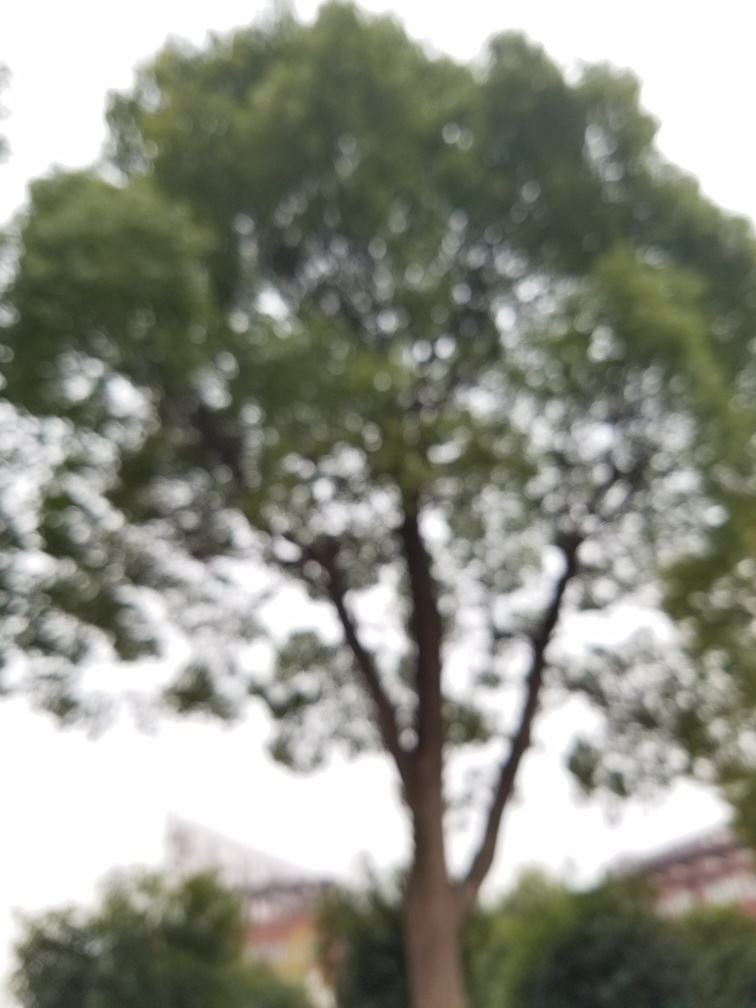What time of day does this photo seem to have been taken? The lighting in the photo suggests overcast conditions or possibly the light of early morning or late afternoon. However, the lack of shadows and direct light sources makes it difficult to determine the exact time of day with certainty. 